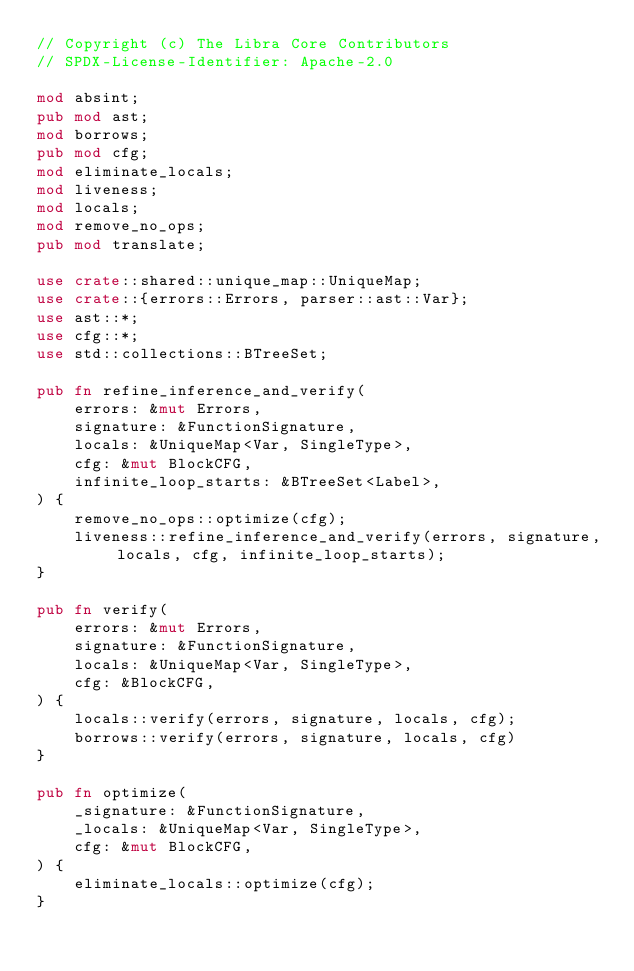<code> <loc_0><loc_0><loc_500><loc_500><_Rust_>// Copyright (c) The Libra Core Contributors
// SPDX-License-Identifier: Apache-2.0

mod absint;
pub mod ast;
mod borrows;
pub mod cfg;
mod eliminate_locals;
mod liveness;
mod locals;
mod remove_no_ops;
pub mod translate;

use crate::shared::unique_map::UniqueMap;
use crate::{errors::Errors, parser::ast::Var};
use ast::*;
use cfg::*;
use std::collections::BTreeSet;

pub fn refine_inference_and_verify(
    errors: &mut Errors,
    signature: &FunctionSignature,
    locals: &UniqueMap<Var, SingleType>,
    cfg: &mut BlockCFG,
    infinite_loop_starts: &BTreeSet<Label>,
) {
    remove_no_ops::optimize(cfg);
    liveness::refine_inference_and_verify(errors, signature, locals, cfg, infinite_loop_starts);
}

pub fn verify(
    errors: &mut Errors,
    signature: &FunctionSignature,
    locals: &UniqueMap<Var, SingleType>,
    cfg: &BlockCFG,
) {
    locals::verify(errors, signature, locals, cfg);
    borrows::verify(errors, signature, locals, cfg)
}

pub fn optimize(
    _signature: &FunctionSignature,
    _locals: &UniqueMap<Var, SingleType>,
    cfg: &mut BlockCFG,
) {
    eliminate_locals::optimize(cfg);
}
</code> 